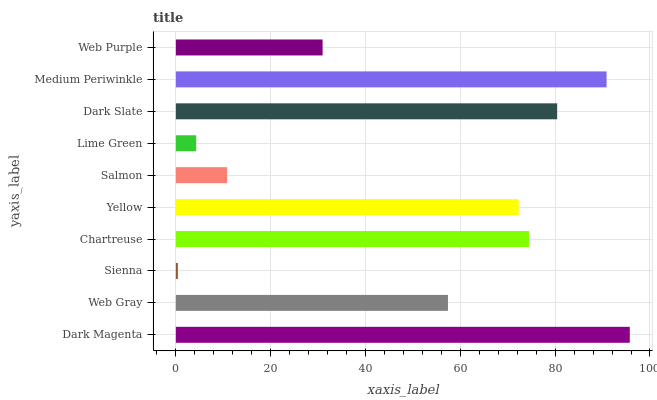Is Sienna the minimum?
Answer yes or no. Yes. Is Dark Magenta the maximum?
Answer yes or no. Yes. Is Web Gray the minimum?
Answer yes or no. No. Is Web Gray the maximum?
Answer yes or no. No. Is Dark Magenta greater than Web Gray?
Answer yes or no. Yes. Is Web Gray less than Dark Magenta?
Answer yes or no. Yes. Is Web Gray greater than Dark Magenta?
Answer yes or no. No. Is Dark Magenta less than Web Gray?
Answer yes or no. No. Is Yellow the high median?
Answer yes or no. Yes. Is Web Gray the low median?
Answer yes or no. Yes. Is Salmon the high median?
Answer yes or no. No. Is Web Purple the low median?
Answer yes or no. No. 